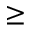Convert formula to latex. <formula><loc_0><loc_0><loc_500><loc_500>\geq</formula> 